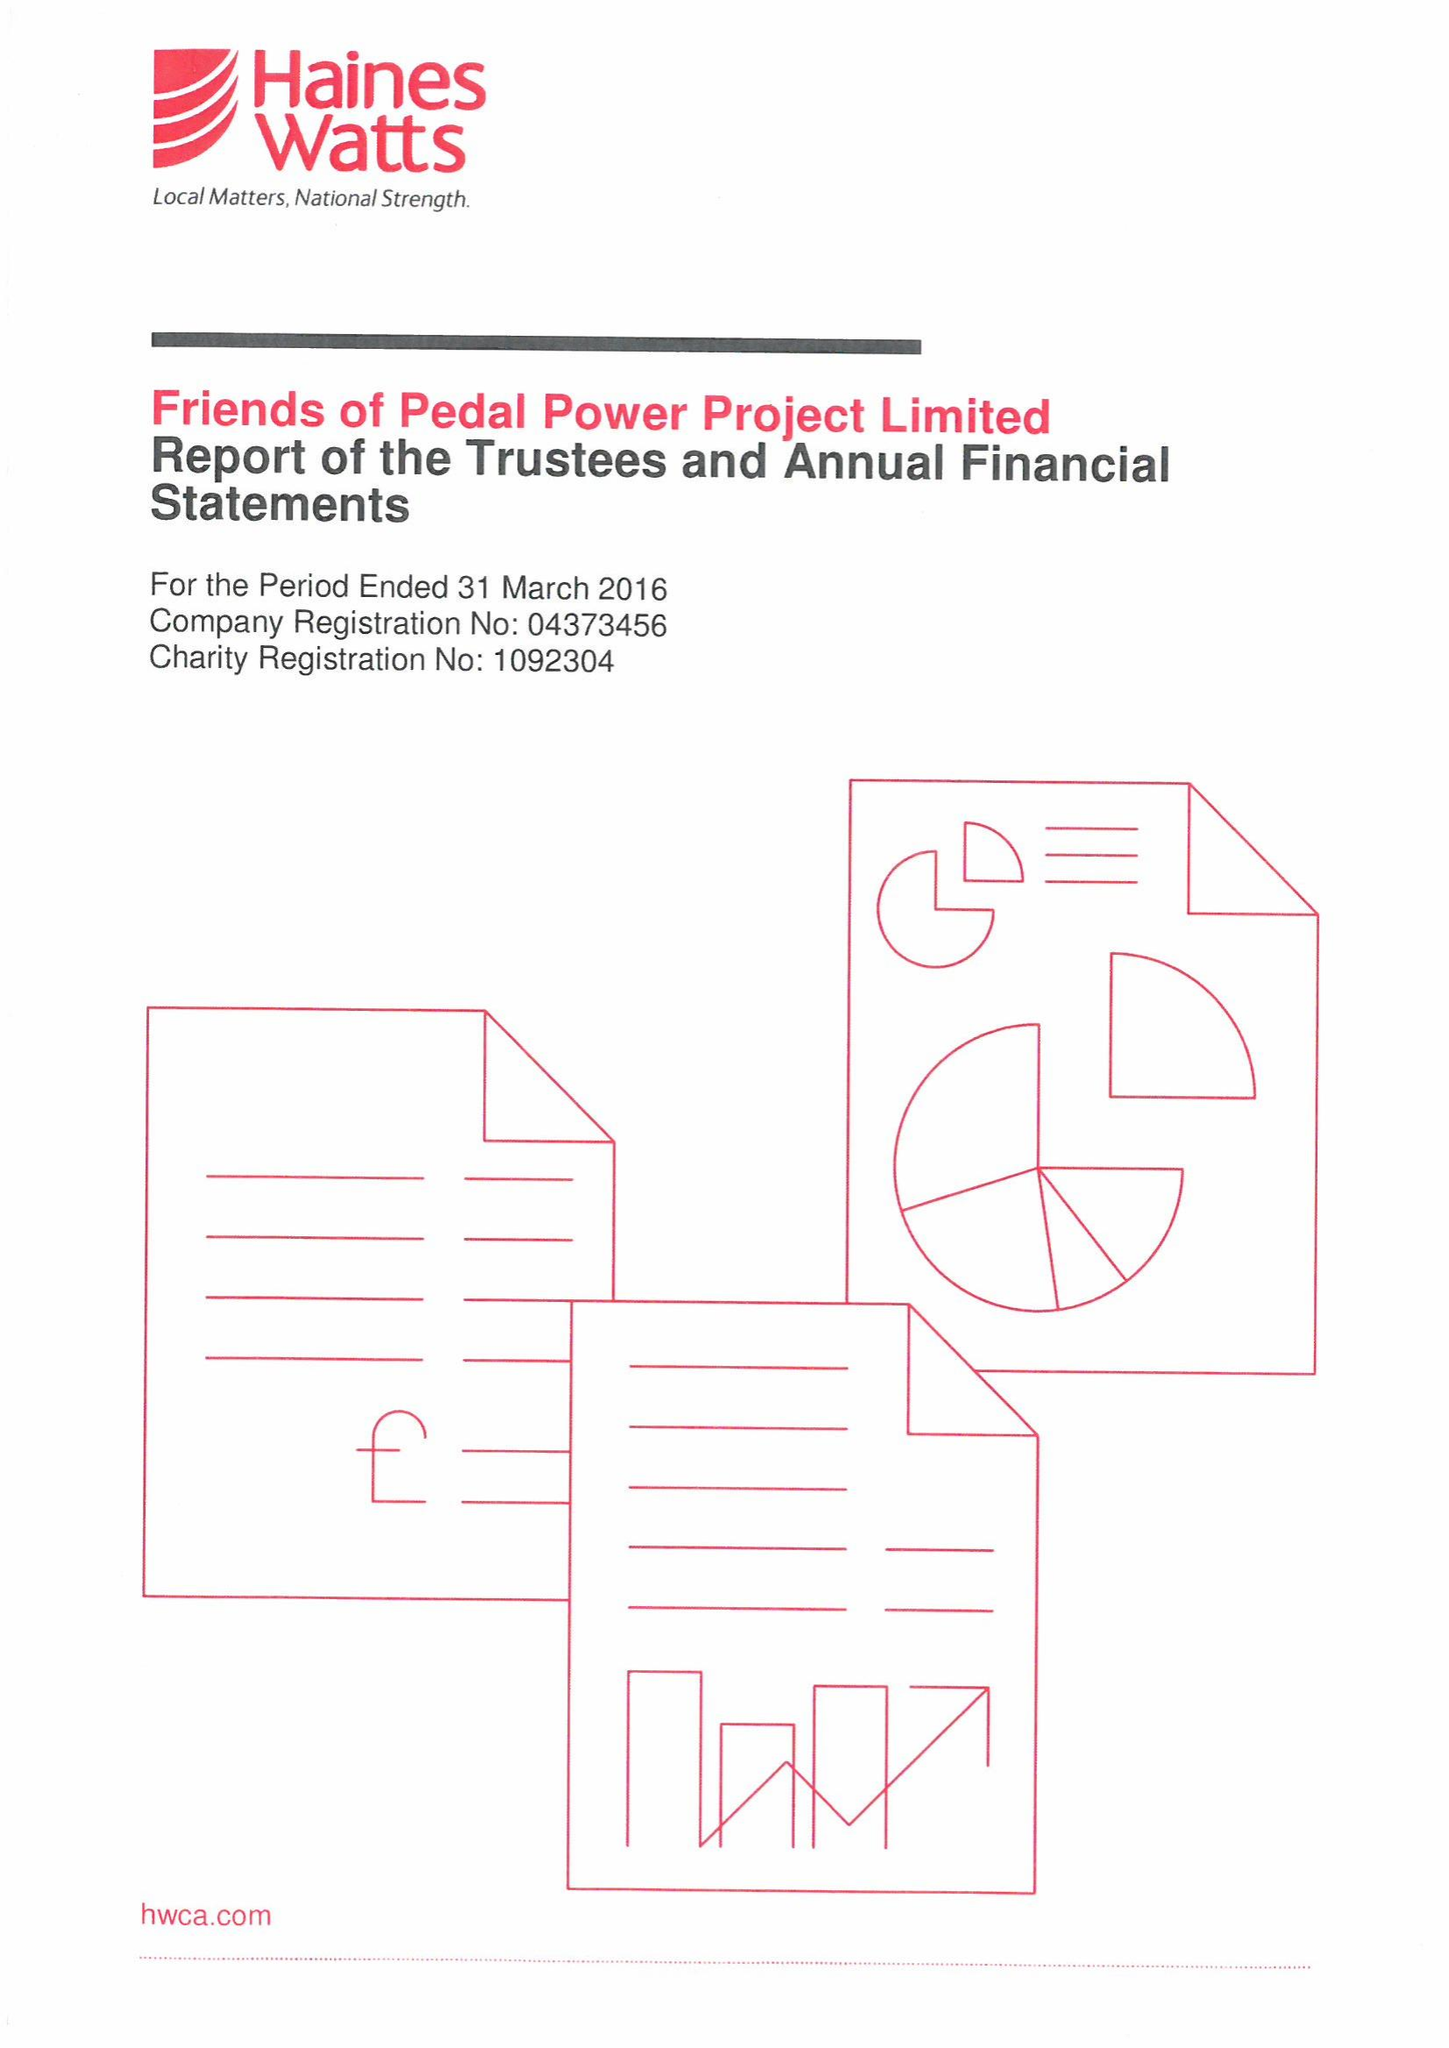What is the value for the income_annually_in_british_pounds?
Answer the question using a single word or phrase. 372743.00 